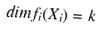Convert formula to latex. <formula><loc_0><loc_0><loc_500><loc_500>d i m f _ { i } ( X _ { i } ) = k</formula> 